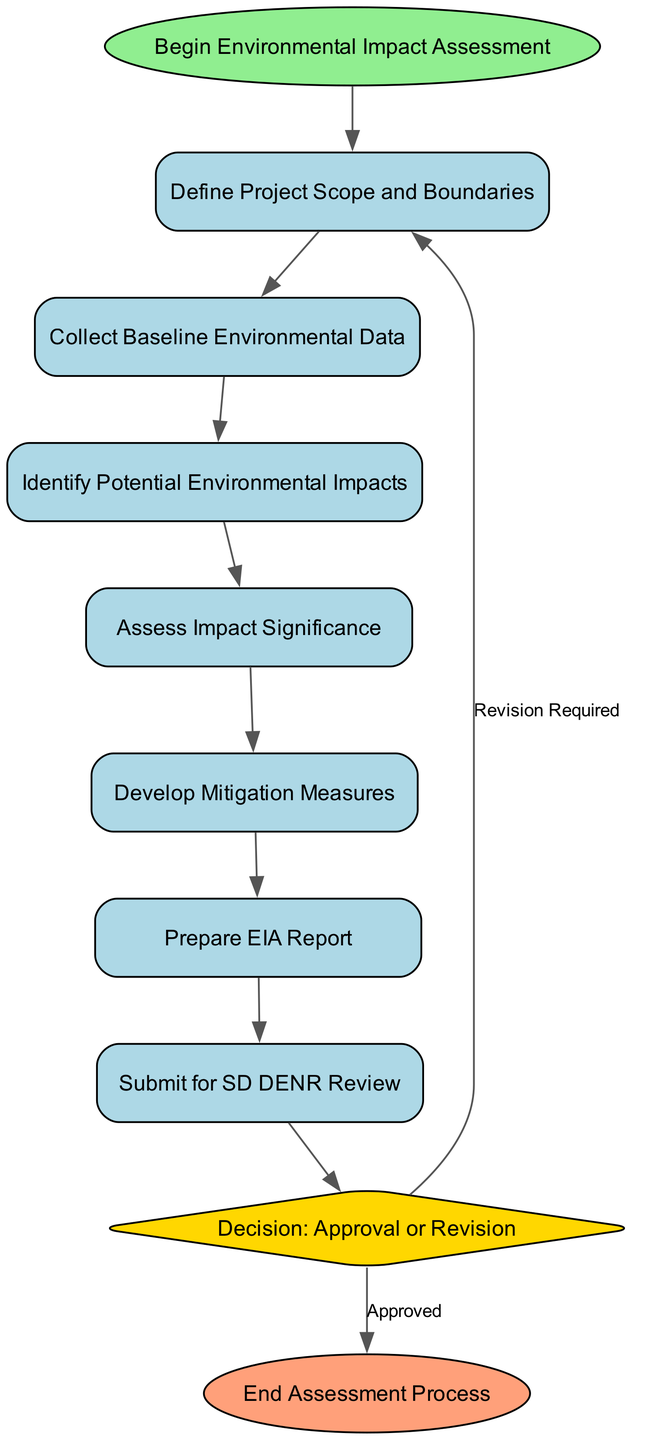What is the first step in the Environmental Impact Assessment workflow? The first step is indicated by the "start" node, which states "Begin Environmental Impact Assessment." This is where the process initiates.
Answer: Begin Environmental Impact Assessment How many total nodes are present in the diagram? By counting the nodes listed in the data, there are ten distinct nodes that represent various steps in the workflow of the environmental impact assessment.
Answer: 10 What is the purpose of the "decision" node? The "decision" node, shaped like a diamond, indicates a point in the workflow where a decision is made regarding the outcome of the EIA process, specifically whether it is approved or revision is required.
Answer: Decision: Approval or Revision Which node follows "Develop Mitigation Measures"? The diagram shows that the node "Prepare EIA Report" directly follows "Develop Mitigation Measures," indicating that after measures are developed, the next step is to prepare the report.
Answer: Prepare EIA Report If the decision is "Revision Required," which step is the workflow returned to? If the decision from the "decision" node indicates "Revision Required," the diagram shows an edge returning to the "Define Project Scope and Boundaries," indicating that the process will loop back to refine or modify the project scope.
Answer: Define Project Scope and Boundaries How many edges connect the nodes in the diagram? By analyzing the edges provided in the data, there are nine edges that illustrate the connections and flow between the different steps in the assessment process.
Answer: 9 What color is used for the "start" node? The "start" node is assigned a light green color to visually differentiate it from other nodes, indicating its significance as the initial point in the workflow.
Answer: Light green What happens at the "Submit for SD DENR Review" step? At this point in the workflow, the EIA report is submitted to the South Dakota Department of Environment and Natural Resources for review, marking a crucial stage in the assessment process.
Answer: Submit for SD DENR Review 